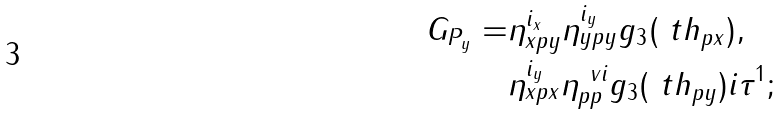<formula> <loc_0><loc_0><loc_500><loc_500>G _ { P _ { y } } = & \eta _ { x p y } ^ { i _ { x } } \eta _ { y p y } ^ { i _ { y } } g _ { 3 } ( \ t h _ { p x } ) , \\ & \eta _ { x p x } ^ { i _ { y } } \eta _ { p p } ^ { \ v i } g _ { 3 } ( \ t h _ { p y } ) i \tau ^ { 1 } ;</formula> 